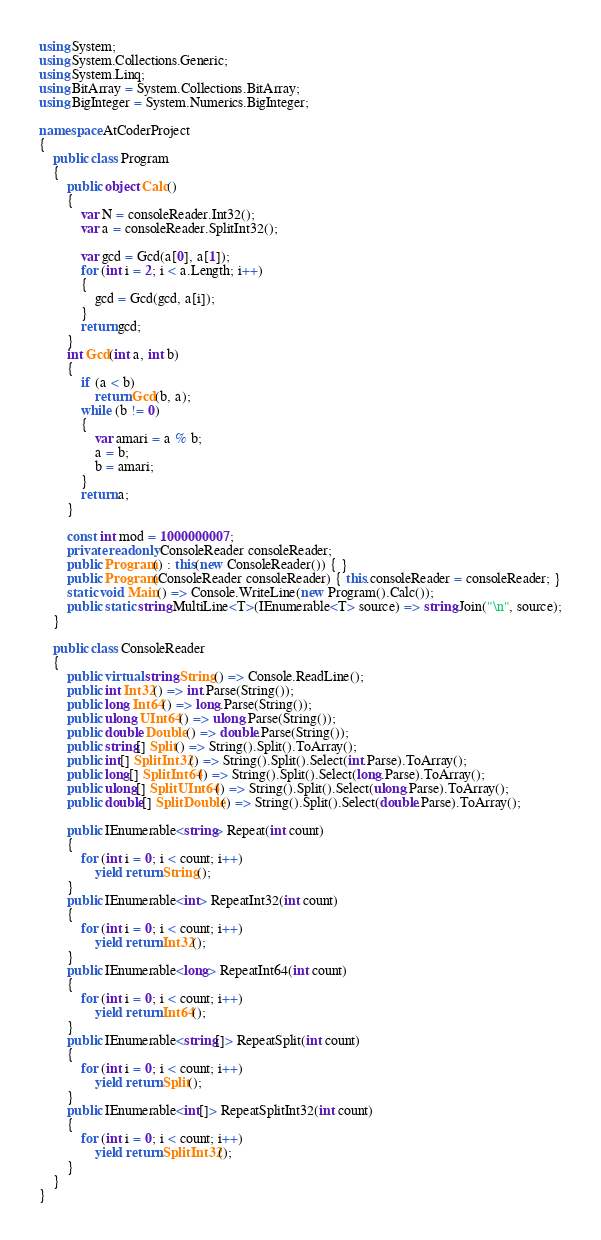Convert code to text. <code><loc_0><loc_0><loc_500><loc_500><_C#_>using System;
using System.Collections.Generic;
using System.Linq;
using BitArray = System.Collections.BitArray;
using BigInteger = System.Numerics.BigInteger;

namespace AtCoderProject
{
    public class Program
    {
        public object Calc()
        {
            var N = consoleReader.Int32();
            var a = consoleReader.SplitInt32();

            var gcd = Gcd(a[0], a[1]);
            for (int i = 2; i < a.Length; i++)
            {
                gcd = Gcd(gcd, a[i]);
            }
            return gcd;
        }
        int Gcd(int a, int b)
        {
            if (a < b)
                return Gcd(b, a);
            while (b != 0)
            {
                var amari = a % b;
                a = b;
                b = amari;
            }
            return a;
        }

        const int mod = 1000000007;
        private readonly ConsoleReader consoleReader;
        public Program() : this(new ConsoleReader()) { }
        public Program(ConsoleReader consoleReader) { this.consoleReader = consoleReader; }
        static void Main() => Console.WriteLine(new Program().Calc());
        public static string MultiLine<T>(IEnumerable<T> source) => string.Join("\n", source);
    }

    public class ConsoleReader
    {
        public virtual string String() => Console.ReadLine();
        public int Int32() => int.Parse(String());
        public long Int64() => long.Parse(String());
        public ulong UInt64() => ulong.Parse(String());
        public double Double() => double.Parse(String());
        public string[] Split() => String().Split().ToArray();
        public int[] SplitInt32() => String().Split().Select(int.Parse).ToArray();
        public long[] SplitInt64() => String().Split().Select(long.Parse).ToArray();
        public ulong[] SplitUInt64() => String().Split().Select(ulong.Parse).ToArray();
        public double[] SplitDouble() => String().Split().Select(double.Parse).ToArray();

        public IEnumerable<string> Repeat(int count)
        {
            for (int i = 0; i < count; i++)
                yield return String();
        }
        public IEnumerable<int> RepeatInt32(int count)
        {
            for (int i = 0; i < count; i++)
                yield return Int32();
        }
        public IEnumerable<long> RepeatInt64(int count)
        {
            for (int i = 0; i < count; i++)
                yield return Int64();
        }
        public IEnumerable<string[]> RepeatSplit(int count)
        {
            for (int i = 0; i < count; i++)
                yield return Split();
        }
        public IEnumerable<int[]> RepeatSplitInt32(int count)
        {
            for (int i = 0; i < count; i++)
                yield return SplitInt32();
        }
    }
}
</code> 